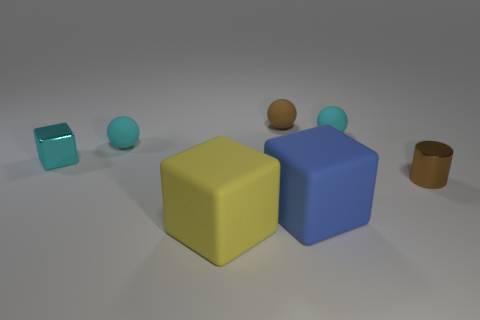Subtract all small cyan matte balls. How many balls are left? 1 Subtract all purple blocks. How many cyan spheres are left? 2 Subtract 1 balls. How many balls are left? 2 Add 2 purple rubber blocks. How many objects exist? 9 Subtract all tiny rubber things. Subtract all small blocks. How many objects are left? 3 Add 1 blue blocks. How many blue blocks are left? 2 Add 6 large blue objects. How many large blue objects exist? 7 Subtract 1 cyan spheres. How many objects are left? 6 Subtract all spheres. How many objects are left? 4 Subtract all green balls. Subtract all red cylinders. How many balls are left? 3 